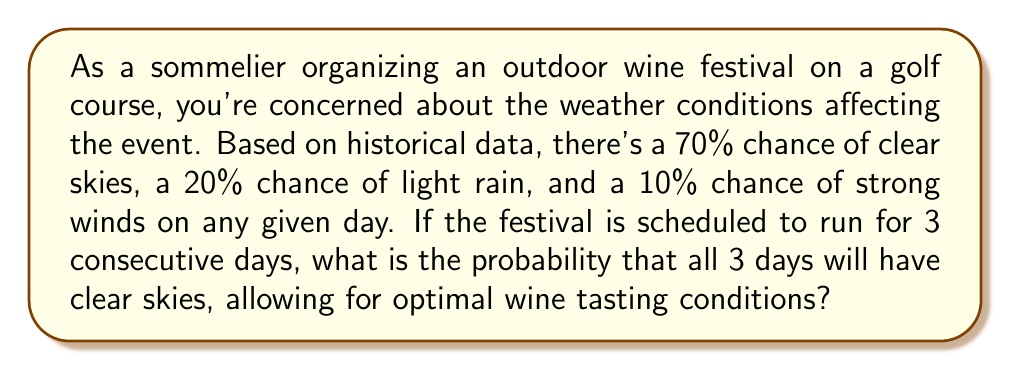Solve this math problem. To solve this problem, we need to use the concept of independent events and probability multiplication.

1. First, let's identify the probability of clear skies on a single day:
   $P(\text{clear skies}) = 0.70$ or 70%

2. We want the probability of clear skies occurring on all 3 days of the festival. Since weather conditions for each day are independent of the other days, we can multiply the probabilities:

   $P(\text{3 days of clear skies}) = P(\text{clear day 1}) \times P(\text{clear day 2}) \times P(\text{clear day 3})$

3. Substituting the probability for each day:

   $P(\text{3 days of clear skies}) = 0.70 \times 0.70 \times 0.70$

4. Calculate the result:

   $P(\text{3 days of clear skies}) = 0.70^3 = 0.343$ or 34.3%

Therefore, the probability of having clear skies on all 3 days of the wine festival is approximately 0.343 or 34.3%.
Answer: The probability of having clear skies on all 3 days of the wine festival is $0.343$ or $34.3\%$. 